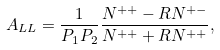<formula> <loc_0><loc_0><loc_500><loc_500>A _ { L L } = \frac { 1 } { P _ { 1 } P _ { 2 } } \frac { N ^ { + + } - R N ^ { + - } } { N ^ { + + } + R N ^ { + + } } ,</formula> 